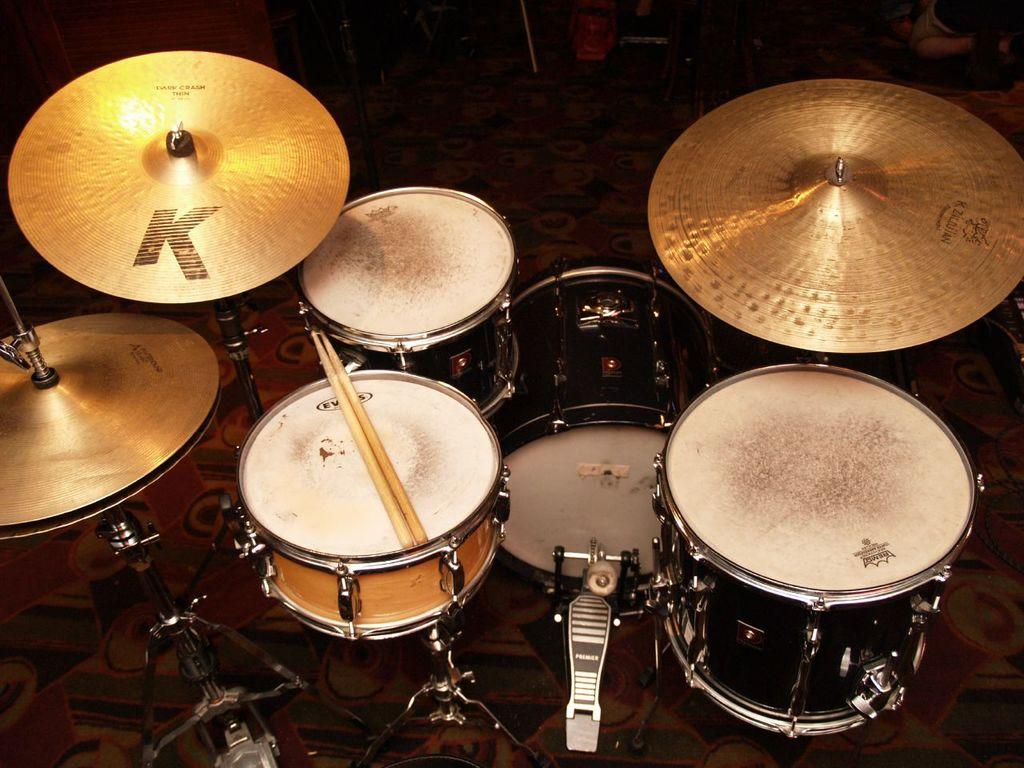What type of musical instruments are present in the image? There are drums and a hi-hat instrument in the image. How is the hi-hat positioned in the image? The hi-hat is placed on the floor in the image. What are the drummers using to play the drums? Drum sticks are visible in the image, which are used to play the drums. Where are the drum sticks placed when not in use? The drum sticks are placed on a drum head when not in use. How many maids are present in the image, and what tasks are they performing? There are no maids present in the image; it features musical instruments and related equipment. 